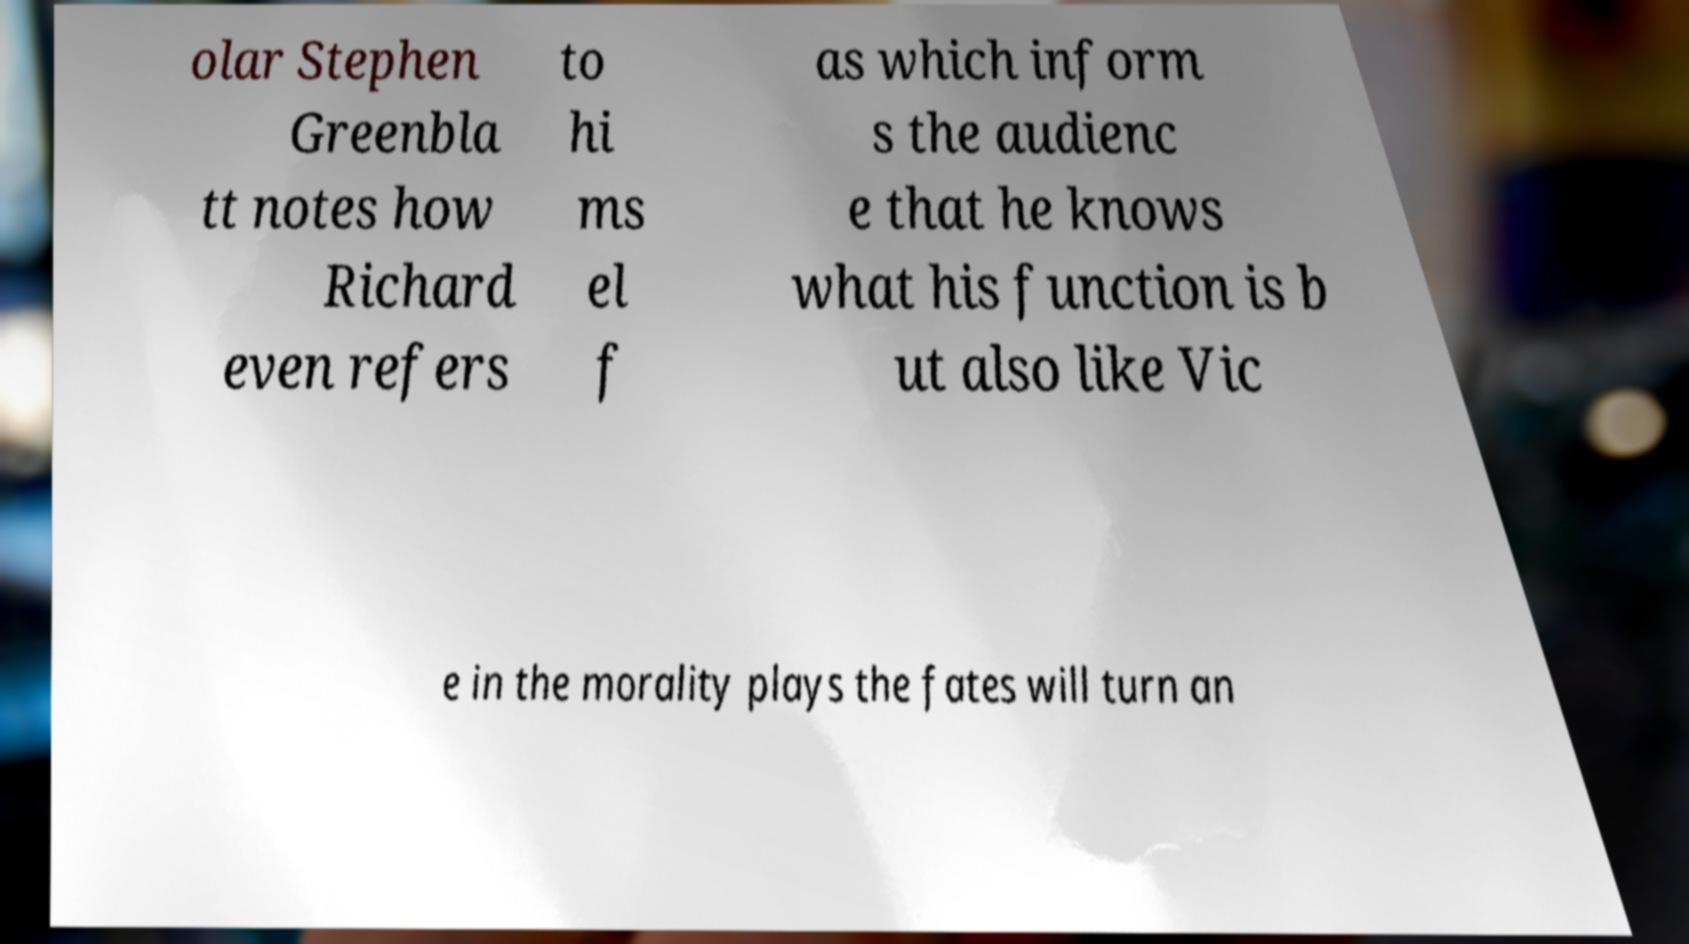Can you read and provide the text displayed in the image?This photo seems to have some interesting text. Can you extract and type it out for me? olar Stephen Greenbla tt notes how Richard even refers to hi ms el f as which inform s the audienc e that he knows what his function is b ut also like Vic e in the morality plays the fates will turn an 